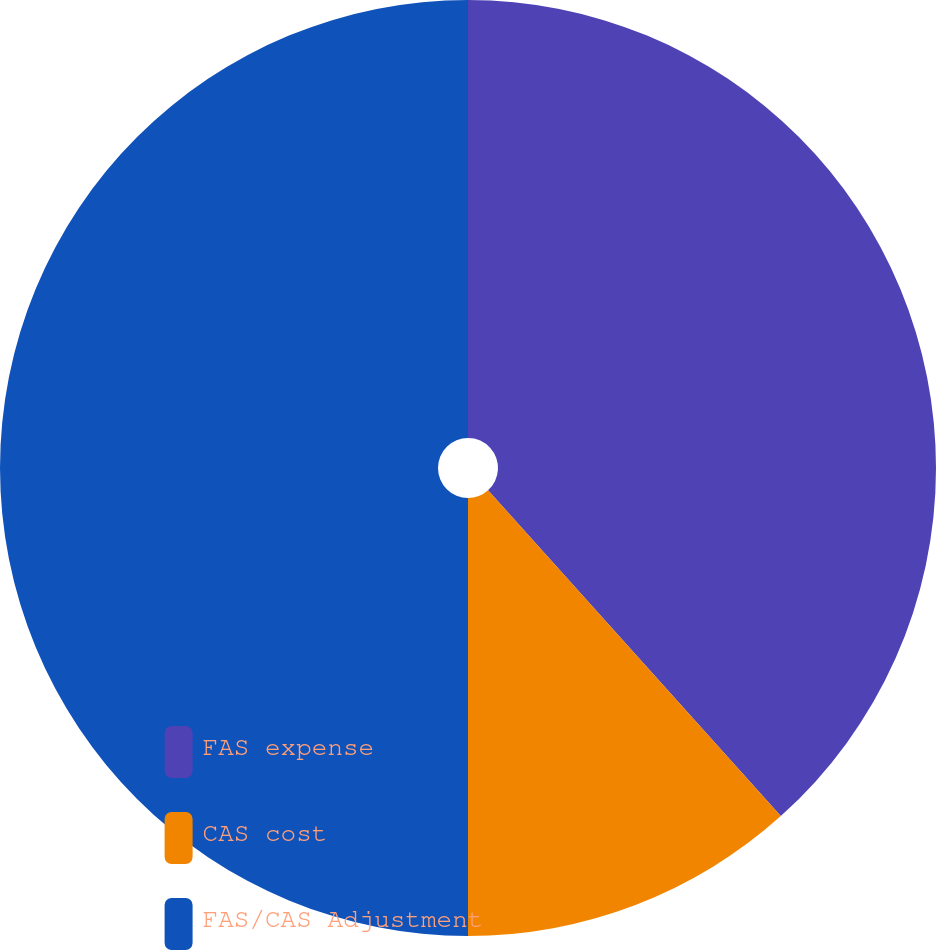Convert chart. <chart><loc_0><loc_0><loc_500><loc_500><pie_chart><fcel>FAS expense<fcel>CAS cost<fcel>FAS/CAS Adjustment<nl><fcel>38.35%<fcel>11.65%<fcel>50.0%<nl></chart> 